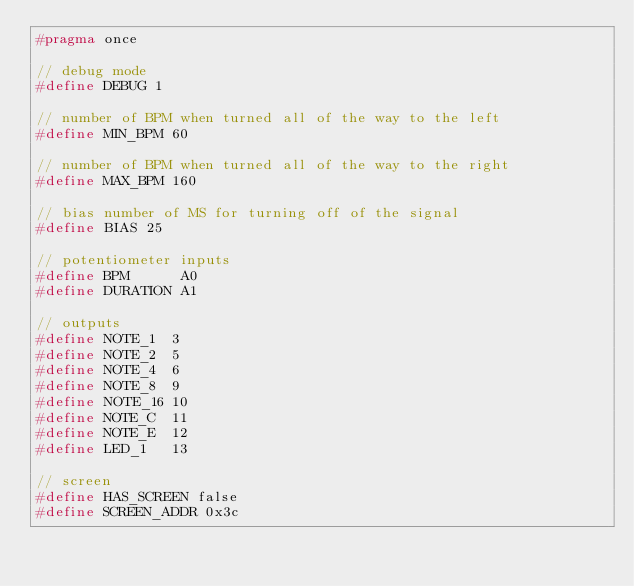Convert code to text. <code><loc_0><loc_0><loc_500><loc_500><_C_>#pragma once

// debug mode
#define DEBUG 1

// number of BPM when turned all of the way to the left
#define MIN_BPM 60

// number of BPM when turned all of the way to the right
#define MAX_BPM 160

// bias number of MS for turning off of the signal
#define BIAS 25

// potentiometer inputs
#define BPM      A0
#define DURATION A1

// outputs
#define NOTE_1  3
#define NOTE_2  5
#define NOTE_4  6
#define NOTE_8  9
#define NOTE_16 10
#define NOTE_C  11
#define NOTE_E  12
#define LED_1   13

// screen
#define HAS_SCREEN false
#define SCREEN_ADDR 0x3c
</code> 